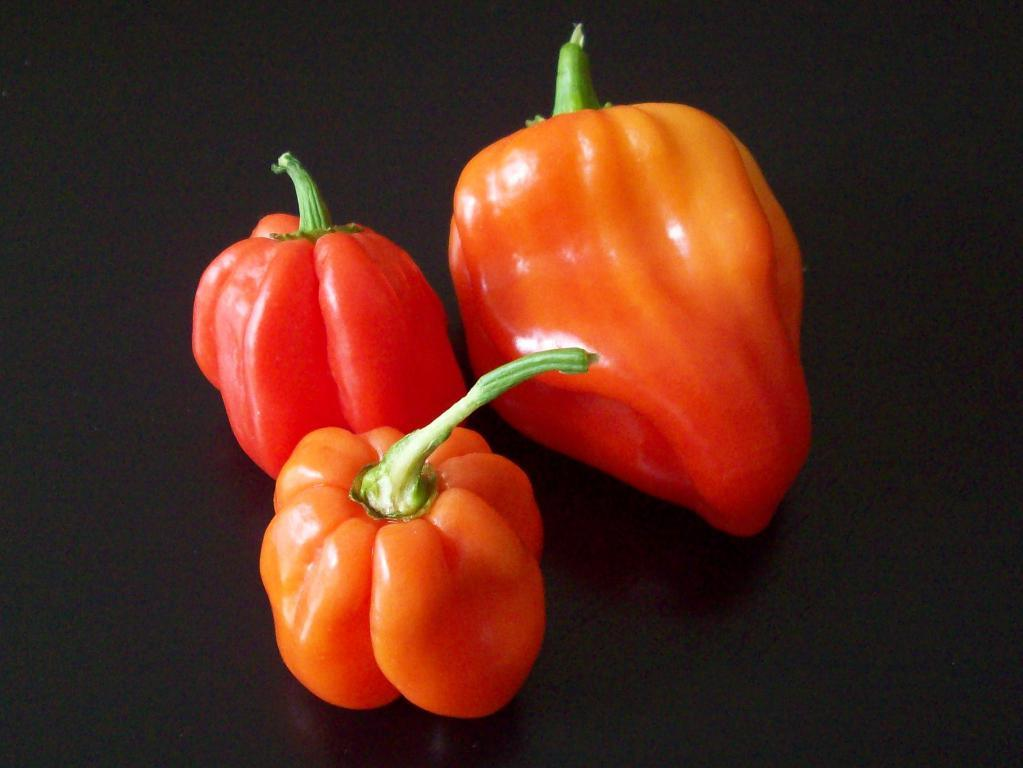What type of vegetable can be seen in the foreground of the image? There are capsicums in the foreground of the image. Where are the capsicums located? The capsicums are on a surface. What type of smile can be seen on the capsicum in the image? There is no smile present on the capsicum in the image, as it is a vegetable and does not have facial expressions. 